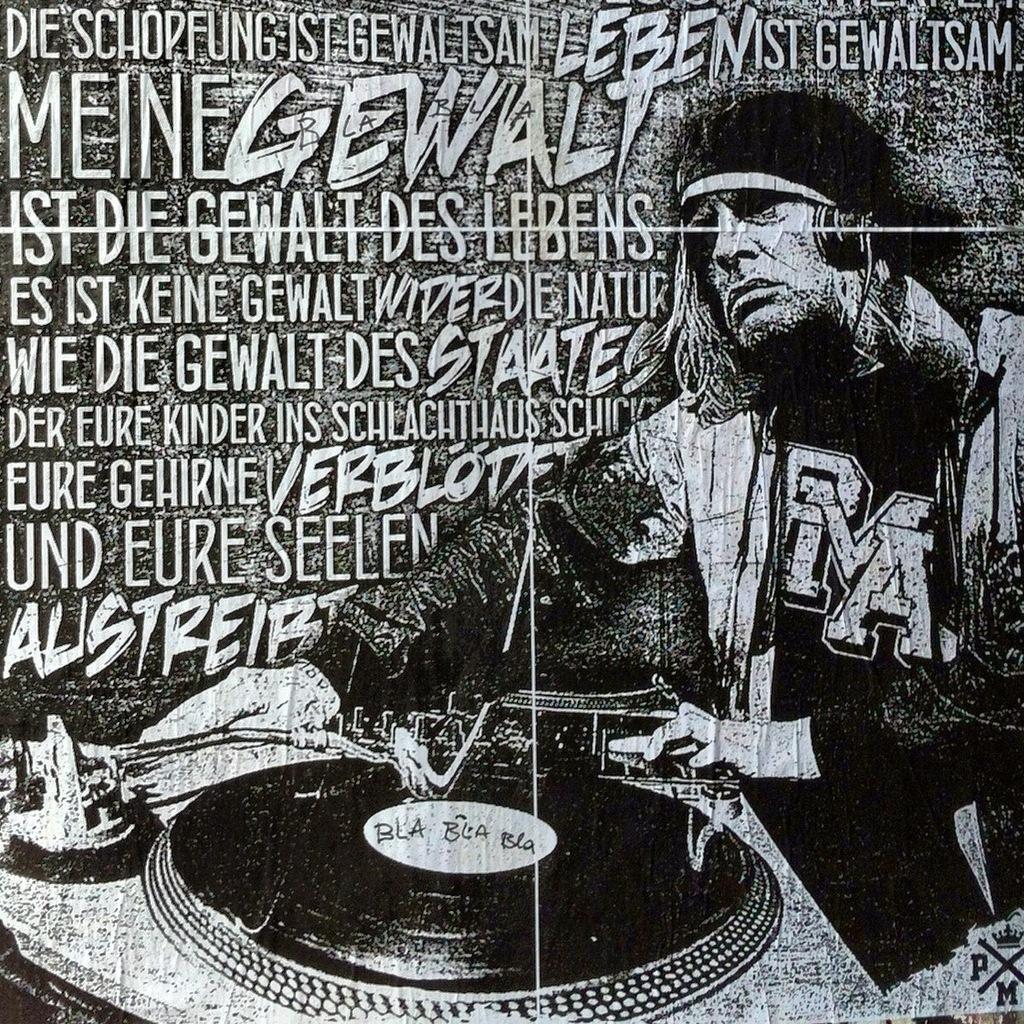What is the color scheme of the poster in the image? The poster is black and white. What is the main subject of the poster? There is a person with an instrument in the poster. What else is featured on the poster besides the person and the instrument? There is text on the poster. Can you tell me how many oranges are depicted on the poster? There are no oranges present on the poster; it features a person with an instrument and text. What type of comfort can be found in the poster? The poster does not depict any type of comfort; it features a person with an instrument and text. 